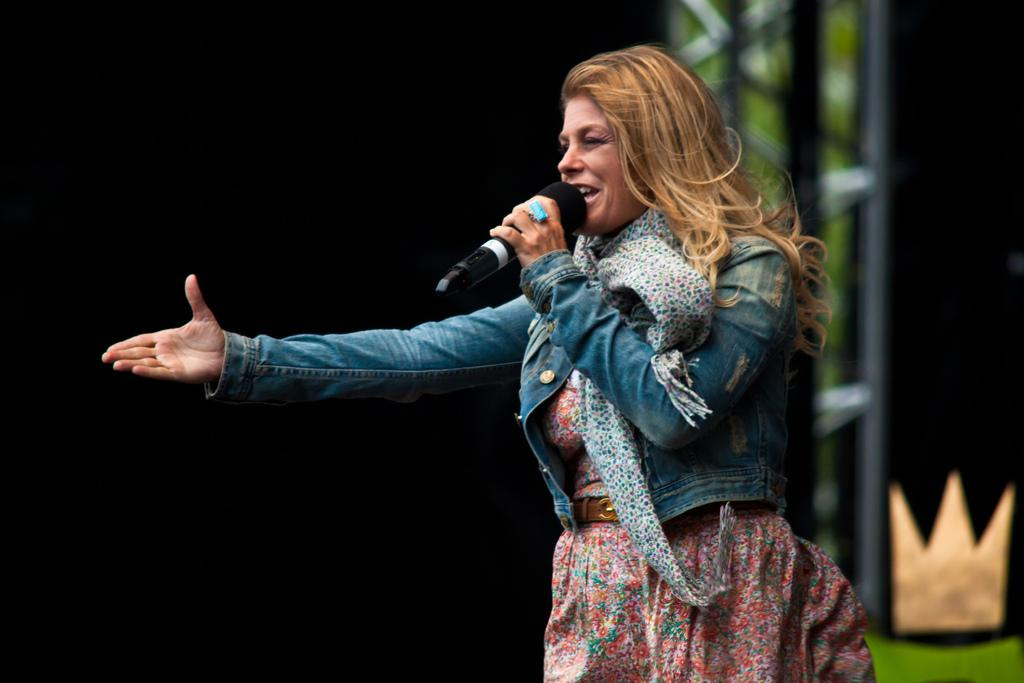Who is the main subject in the image? There is a lady in the image. What is the lady doing in the image? The lady is standing and holding a mic in her hand. What can be seen in the background of the image? There is an iron stand in the background of the image. How many cents are visible on the lady's clothing in the image? There are no cents visible on the lady's clothing in the image. What type of plantation can be seen in the background of the image? There is no plantation present in the image; it features a lady standing with a mic and an iron stand in the background. 